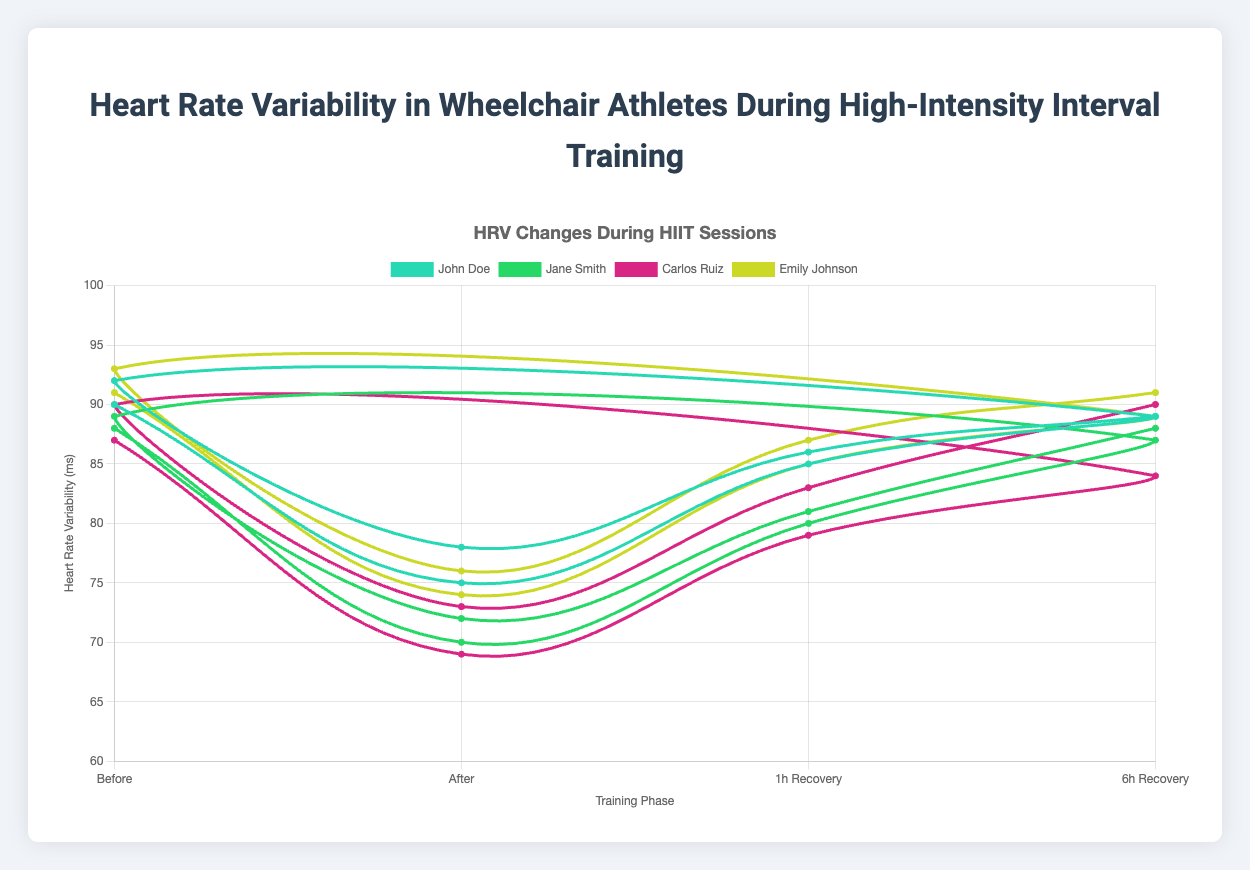Which athlete had the highest HRV before training in any session? Emily Johnson had the highest HRV value before training across all sessions. During her session on 2023-10-11, her HRV was 93 ms before training.
Answer: Emily Johnson Which athlete showed the smallest HRV decrease from before to after training in any session? To determine this, we calculate the HRV difference before and after training for each session of every athlete. John Doe during the session on 2023-10-08 has the smallest HRV decrease of 14 ms (92 - 78 = 14 ms).
Answer: John Doe Whose HRV recovered the most within 6 hours post-training in any session? We need to calculate the difference between HRV after training and HRV at 6-hour recovery for each session. Carlos Ruiz in his session on 2023-10-03 had the maximum recovery, where his HRV went from 69 to 84 ms, a difference of 15 ms.
Answer: Carlos Ruiz What is the average HRV before training for all athletes combined? Sum the HRV before training for all sessions and divide by the number of sessions. The sum is: 90 + 92 + 88 + 89 + 87 + 90 + 91 + 93 = 720 ms. There are 8 sessions, so 720 / 8 = 90 ms.
Answer: 90 ms Which athlete's HRV increased the most from 1 hour to 6 hours post-training in their second session? Calculate the difference between HRV at 6-hour recovery and HRV at 1-hour recovery from the second session of each athlete. Emily Johnson shows the largest increase: 91 - 87 = 4 ms.
Answer: Emily Johnson Who had the biggest decrease in HRV from before to after training in their first session? Compute the difference before and after training for each athlete's first session. Carlos Ruiz saw the largest decrease, with his HRV going from 87 to 69 ms, a difference of 18 ms.
Answer: Carlos Ruiz Which athlete had the most consistent HRV before training across their sessions? To determine consistency, observe the HRV before training values for each athlete's sessions. Emily Johnson has the smallest range: 93 - 91 = 2 ms.
Answer: Emily Johnson On average, how does the HRV change from after training to 1-hour recovery for all sessions combined? Sum the differences between HRV at 1-hour recovery and after training for all sessions, then divide by the number of sessions. The sum is: (85-75) + (86-78) + (80-70) + (81-72) + (79-69) + (83-73) + (85-74) + (87-76) = 40. Divide by 8 sessions: 40 / 8 = 5 ms.
Answer: 5 ms Which athlete had the highest HRV at 6-hour recovery in any session? Check the HRV values at 6-hour recovery of each session. Emily Johnson had the highest HRV of 91 ms in her session on 2023-10-11.
Answer: Emily Johnson 